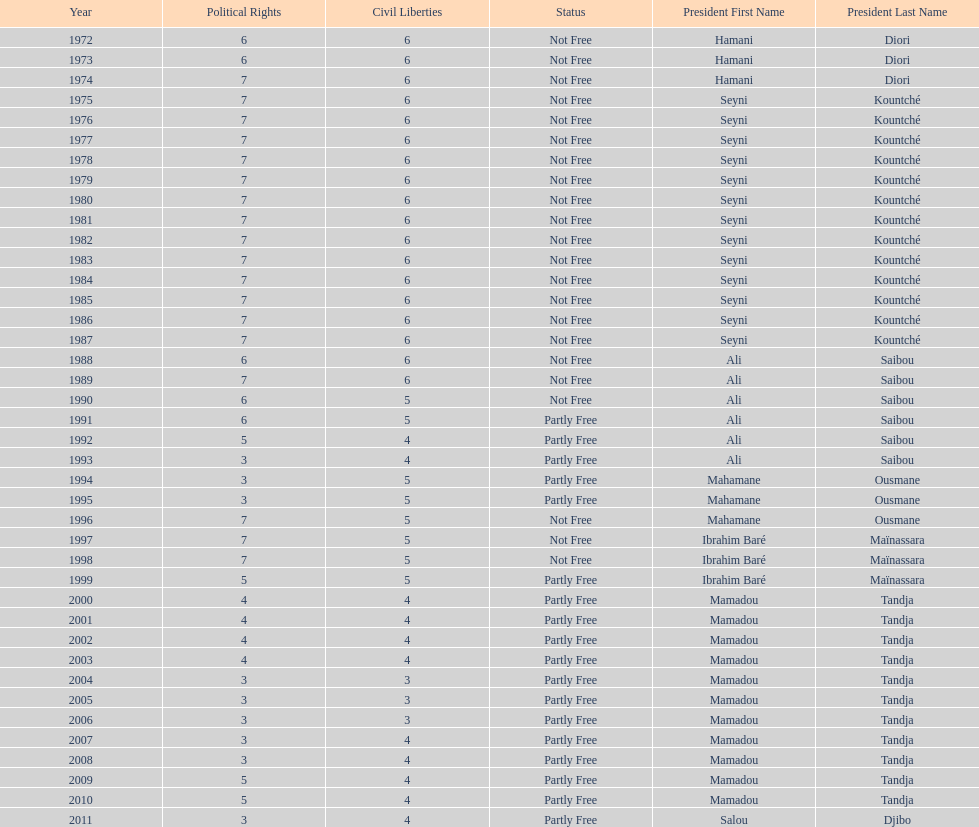What is the number of time seyni kountche has been president? 13. 